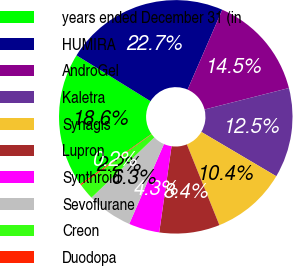Convert chart to OTSL. <chart><loc_0><loc_0><loc_500><loc_500><pie_chart><fcel>years ended December 31 (in<fcel>HUMIRA<fcel>AndroGel<fcel>Kaletra<fcel>Synagis<fcel>Lupron<fcel>Synthroid<fcel>Sevoflurane<fcel>Creon<fcel>Duodopa<nl><fcel>18.6%<fcel>22.7%<fcel>14.51%<fcel>12.46%<fcel>10.41%<fcel>8.36%<fcel>4.26%<fcel>6.31%<fcel>2.22%<fcel>0.17%<nl></chart> 